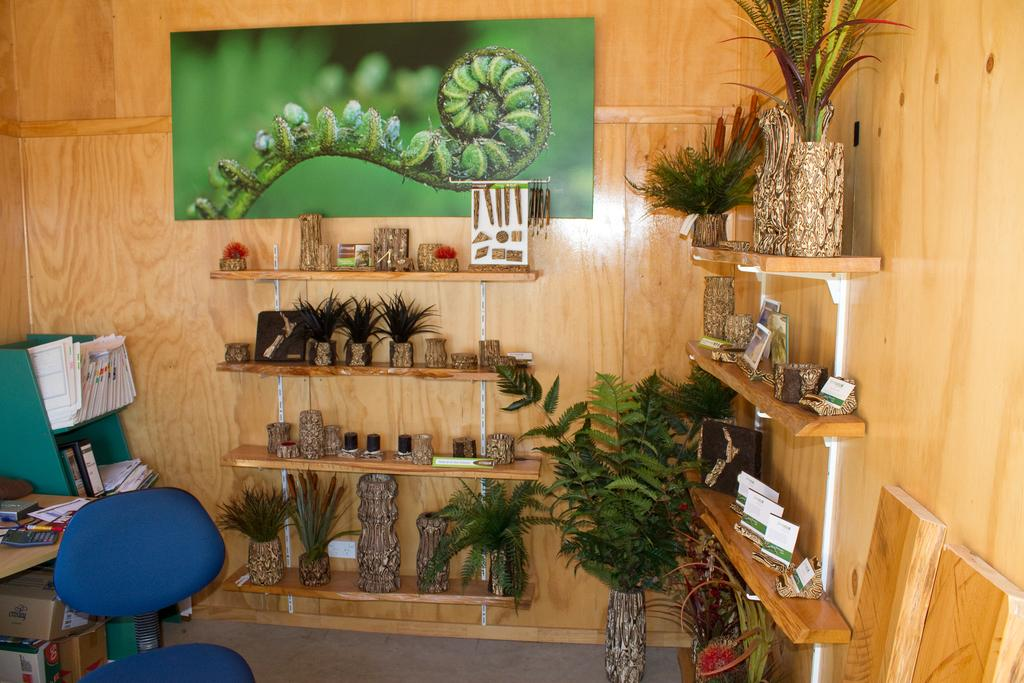What type of space is depicted in the image? The image shows an inner view of a room. What piece of furniture can be seen in the room? There is a chair in the room. What are some items that do not move in the room? Stationary items are present in the room. What can be found on the floor of the room? Cardboard cartons are on the floor. What type of greenery is in the room? Decorative plants are in the room. What is attached to the wall in the room? There is a wall hanging attached to the wall. How many cats are sitting on the chair in the image? There are no cats present in the image; only a chair and other stationary items can be seen. What color are the toenails of the person in the image? There is no person visible in the image, so it is not possible to determine the color of their toenails. 